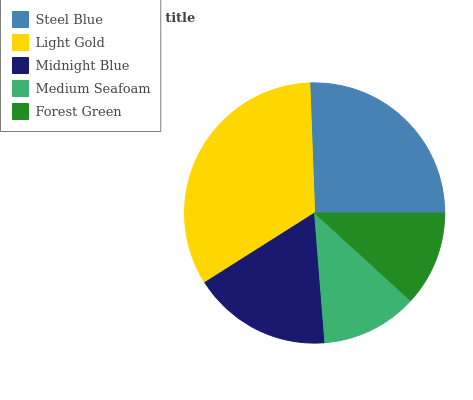Is Forest Green the minimum?
Answer yes or no. Yes. Is Light Gold the maximum?
Answer yes or no. Yes. Is Midnight Blue the minimum?
Answer yes or no. No. Is Midnight Blue the maximum?
Answer yes or no. No. Is Light Gold greater than Midnight Blue?
Answer yes or no. Yes. Is Midnight Blue less than Light Gold?
Answer yes or no. Yes. Is Midnight Blue greater than Light Gold?
Answer yes or no. No. Is Light Gold less than Midnight Blue?
Answer yes or no. No. Is Midnight Blue the high median?
Answer yes or no. Yes. Is Midnight Blue the low median?
Answer yes or no. Yes. Is Light Gold the high median?
Answer yes or no. No. Is Light Gold the low median?
Answer yes or no. No. 